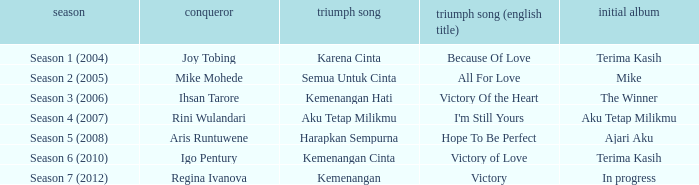Which winning song had a debut album in progress? Kemenangan. 